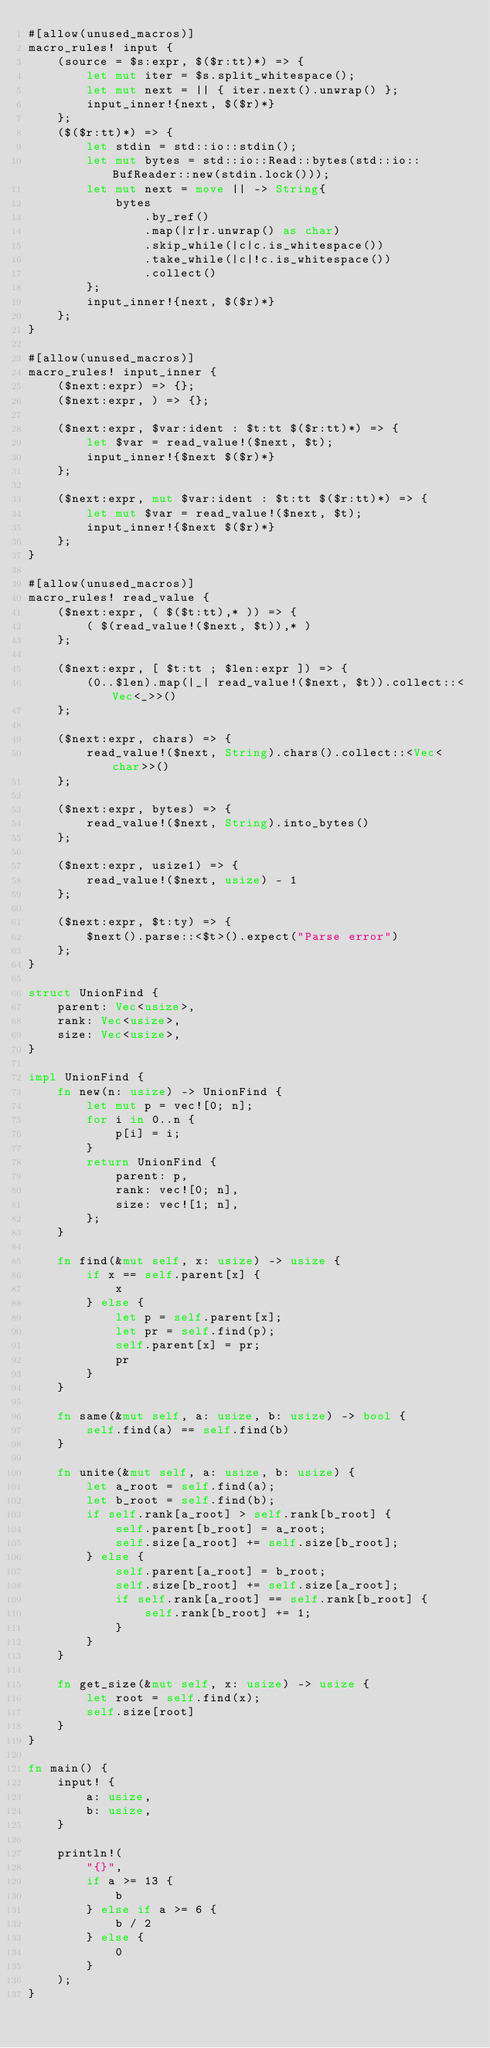Convert code to text. <code><loc_0><loc_0><loc_500><loc_500><_Rust_>#[allow(unused_macros)]
macro_rules! input {
    (source = $s:expr, $($r:tt)*) => {
        let mut iter = $s.split_whitespace();
        let mut next = || { iter.next().unwrap() };
        input_inner!{next, $($r)*}
    };
    ($($r:tt)*) => {
        let stdin = std::io::stdin();
        let mut bytes = std::io::Read::bytes(std::io::BufReader::new(stdin.lock()));
        let mut next = move || -> String{
            bytes
                .by_ref()
                .map(|r|r.unwrap() as char)
                .skip_while(|c|c.is_whitespace())
                .take_while(|c|!c.is_whitespace())
                .collect()
        };
        input_inner!{next, $($r)*}
    };
}

#[allow(unused_macros)]
macro_rules! input_inner {
    ($next:expr) => {};
    ($next:expr, ) => {};

    ($next:expr, $var:ident : $t:tt $($r:tt)*) => {
        let $var = read_value!($next, $t);
        input_inner!{$next $($r)*}
    };

    ($next:expr, mut $var:ident : $t:tt $($r:tt)*) => {
        let mut $var = read_value!($next, $t);
        input_inner!{$next $($r)*}
    };
}

#[allow(unused_macros)]
macro_rules! read_value {
    ($next:expr, ( $($t:tt),* )) => {
        ( $(read_value!($next, $t)),* )
    };

    ($next:expr, [ $t:tt ; $len:expr ]) => {
        (0..$len).map(|_| read_value!($next, $t)).collect::<Vec<_>>()
    };

    ($next:expr, chars) => {
        read_value!($next, String).chars().collect::<Vec<char>>()
    };

    ($next:expr, bytes) => {
        read_value!($next, String).into_bytes()
    };

    ($next:expr, usize1) => {
        read_value!($next, usize) - 1
    };

    ($next:expr, $t:ty) => {
        $next().parse::<$t>().expect("Parse error")
    };
}

struct UnionFind {
    parent: Vec<usize>,
    rank: Vec<usize>,
    size: Vec<usize>,
}

impl UnionFind {
    fn new(n: usize) -> UnionFind {
        let mut p = vec![0; n];
        for i in 0..n {
            p[i] = i;
        }
        return UnionFind {
            parent: p,
            rank: vec![0; n],
            size: vec![1; n],
        };
    }

    fn find(&mut self, x: usize) -> usize {
        if x == self.parent[x] {
            x
        } else {
            let p = self.parent[x];
            let pr = self.find(p);
            self.parent[x] = pr;
            pr
        }
    }

    fn same(&mut self, a: usize, b: usize) -> bool {
        self.find(a) == self.find(b)
    }

    fn unite(&mut self, a: usize, b: usize) {
        let a_root = self.find(a);
        let b_root = self.find(b);
        if self.rank[a_root] > self.rank[b_root] {
            self.parent[b_root] = a_root;
            self.size[a_root] += self.size[b_root];
        } else {
            self.parent[a_root] = b_root;
            self.size[b_root] += self.size[a_root];
            if self.rank[a_root] == self.rank[b_root] {
                self.rank[b_root] += 1;
            }
        }
    }

    fn get_size(&mut self, x: usize) -> usize {
        let root = self.find(x);
        self.size[root]
    }
}

fn main() {
    input! {
        a: usize,
        b: usize,
    }

    println!(
        "{}",
        if a >= 13 {
            b
        } else if a >= 6 {
            b / 2
        } else {
            0
        }
    );
}
</code> 